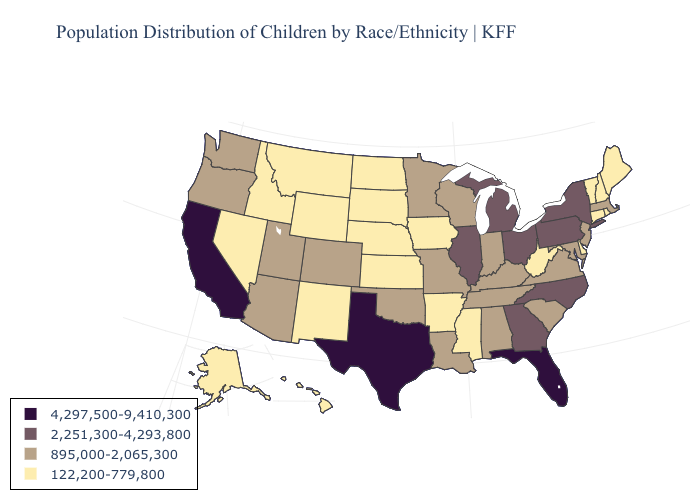Does Nebraska have the lowest value in the MidWest?
Write a very short answer. Yes. Name the states that have a value in the range 4,297,500-9,410,300?
Answer briefly. California, Florida, Texas. Does the map have missing data?
Quick response, please. No. Does Hawaii have the same value as Wyoming?
Quick response, please. Yes. Among the states that border Idaho , does Oregon have the lowest value?
Be succinct. No. What is the highest value in the MidWest ?
Quick response, please. 2,251,300-4,293,800. What is the value of Maryland?
Concise answer only. 895,000-2,065,300. What is the value of Tennessee?
Concise answer only. 895,000-2,065,300. Does California have the highest value in the West?
Write a very short answer. Yes. What is the lowest value in the USA?
Short answer required. 122,200-779,800. Does Mississippi have the lowest value in the USA?
Concise answer only. Yes. What is the highest value in the USA?
Write a very short answer. 4,297,500-9,410,300. Name the states that have a value in the range 4,297,500-9,410,300?
Be succinct. California, Florida, Texas. Name the states that have a value in the range 2,251,300-4,293,800?
Be succinct. Georgia, Illinois, Michigan, New York, North Carolina, Ohio, Pennsylvania. 